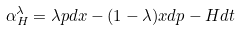Convert formula to latex. <formula><loc_0><loc_0><loc_500><loc_500>\alpha _ { H } ^ { \lambda } = \lambda p d x - ( 1 - \lambda ) x d p - H d t</formula> 